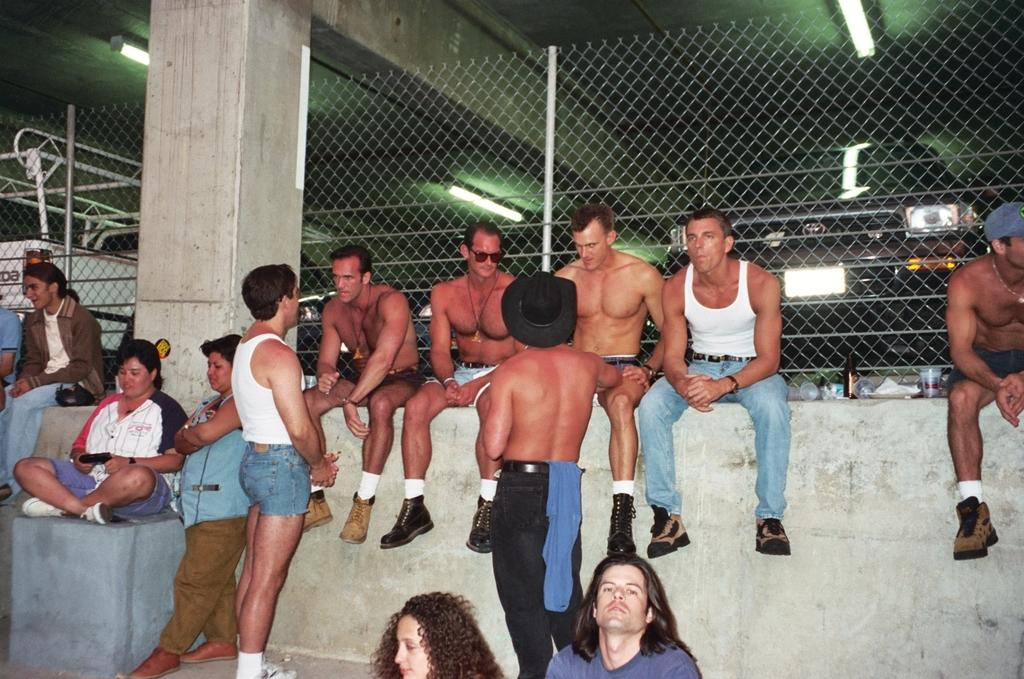How many people are in the image? There is a group of people in the image, but the exact number is not specified. What are the people in the image doing? Some people are seated, while others are standing. What can be seen in the background of the image? There are metal rods visible in the image, as well as a fence and lights. What type of print can be seen on the people's clothing in the image? There is no information about the people's clothing or any prints on them in the provided facts. 